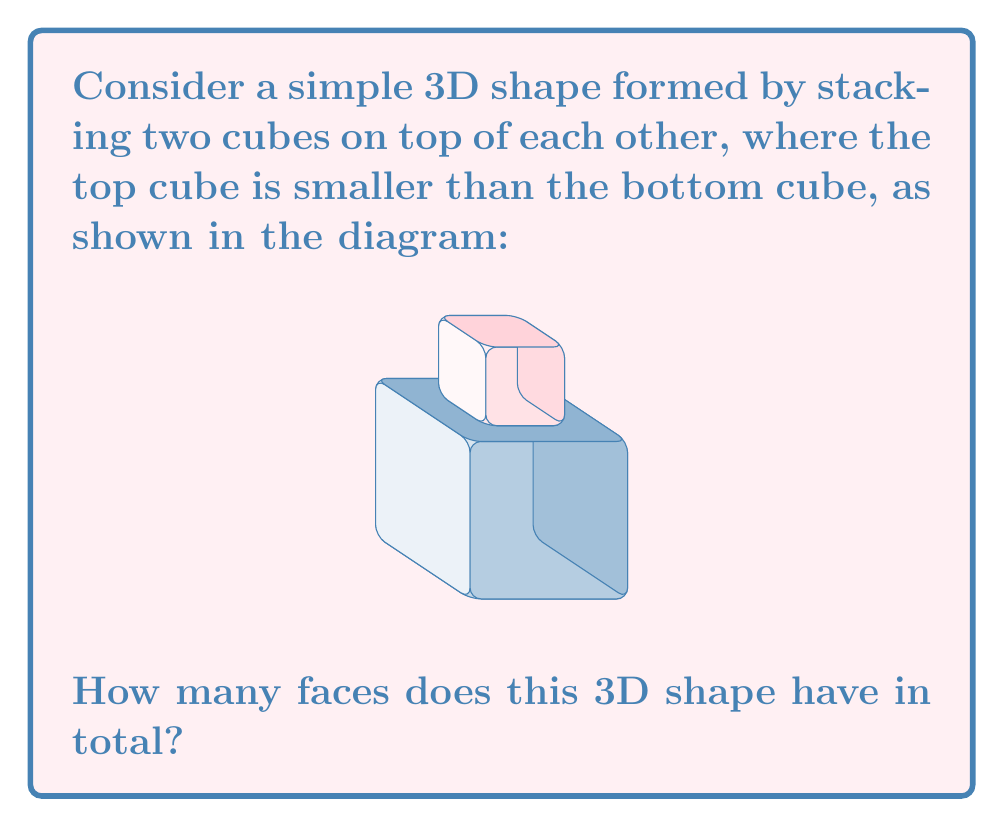Teach me how to tackle this problem. Let's break this down step-by-step:

1. First, let's consider the bottom cube:
   - It has 6 faces, but the top face is partially covered by the smaller cube.
   - So we count 5 fully visible faces from the bottom cube.

2. Now, let's look at the top cube:
   - It also has 6 faces.
   - Its bottom face is not visible as it's in contact with the bottom cube.
   - So we count 5 visible faces from the top cube.

3. Finally, we need to consider the "new" face created where the two cubes meet:
   - This is the visible part of the top face of the bottom cube.
   - It forms a ring-like shape around the base of the top cube.
   - This counts as 1 additional face.

4. To get the total number of faces, we sum up:
   $$\text{Total faces} = 5 + 5 + 1 = 11$$

Therefore, this 3D shape has 11 faces in total.
Answer: 11 faces 